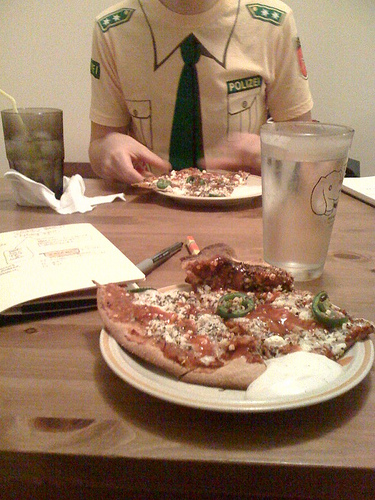How many kites are flying higher than 10 feet? It appears there was a misinterpretation of the scene, as no kites are visible in the image at all. The image actually shows a person at a dining table with pieces of pizza and a glass of water. 